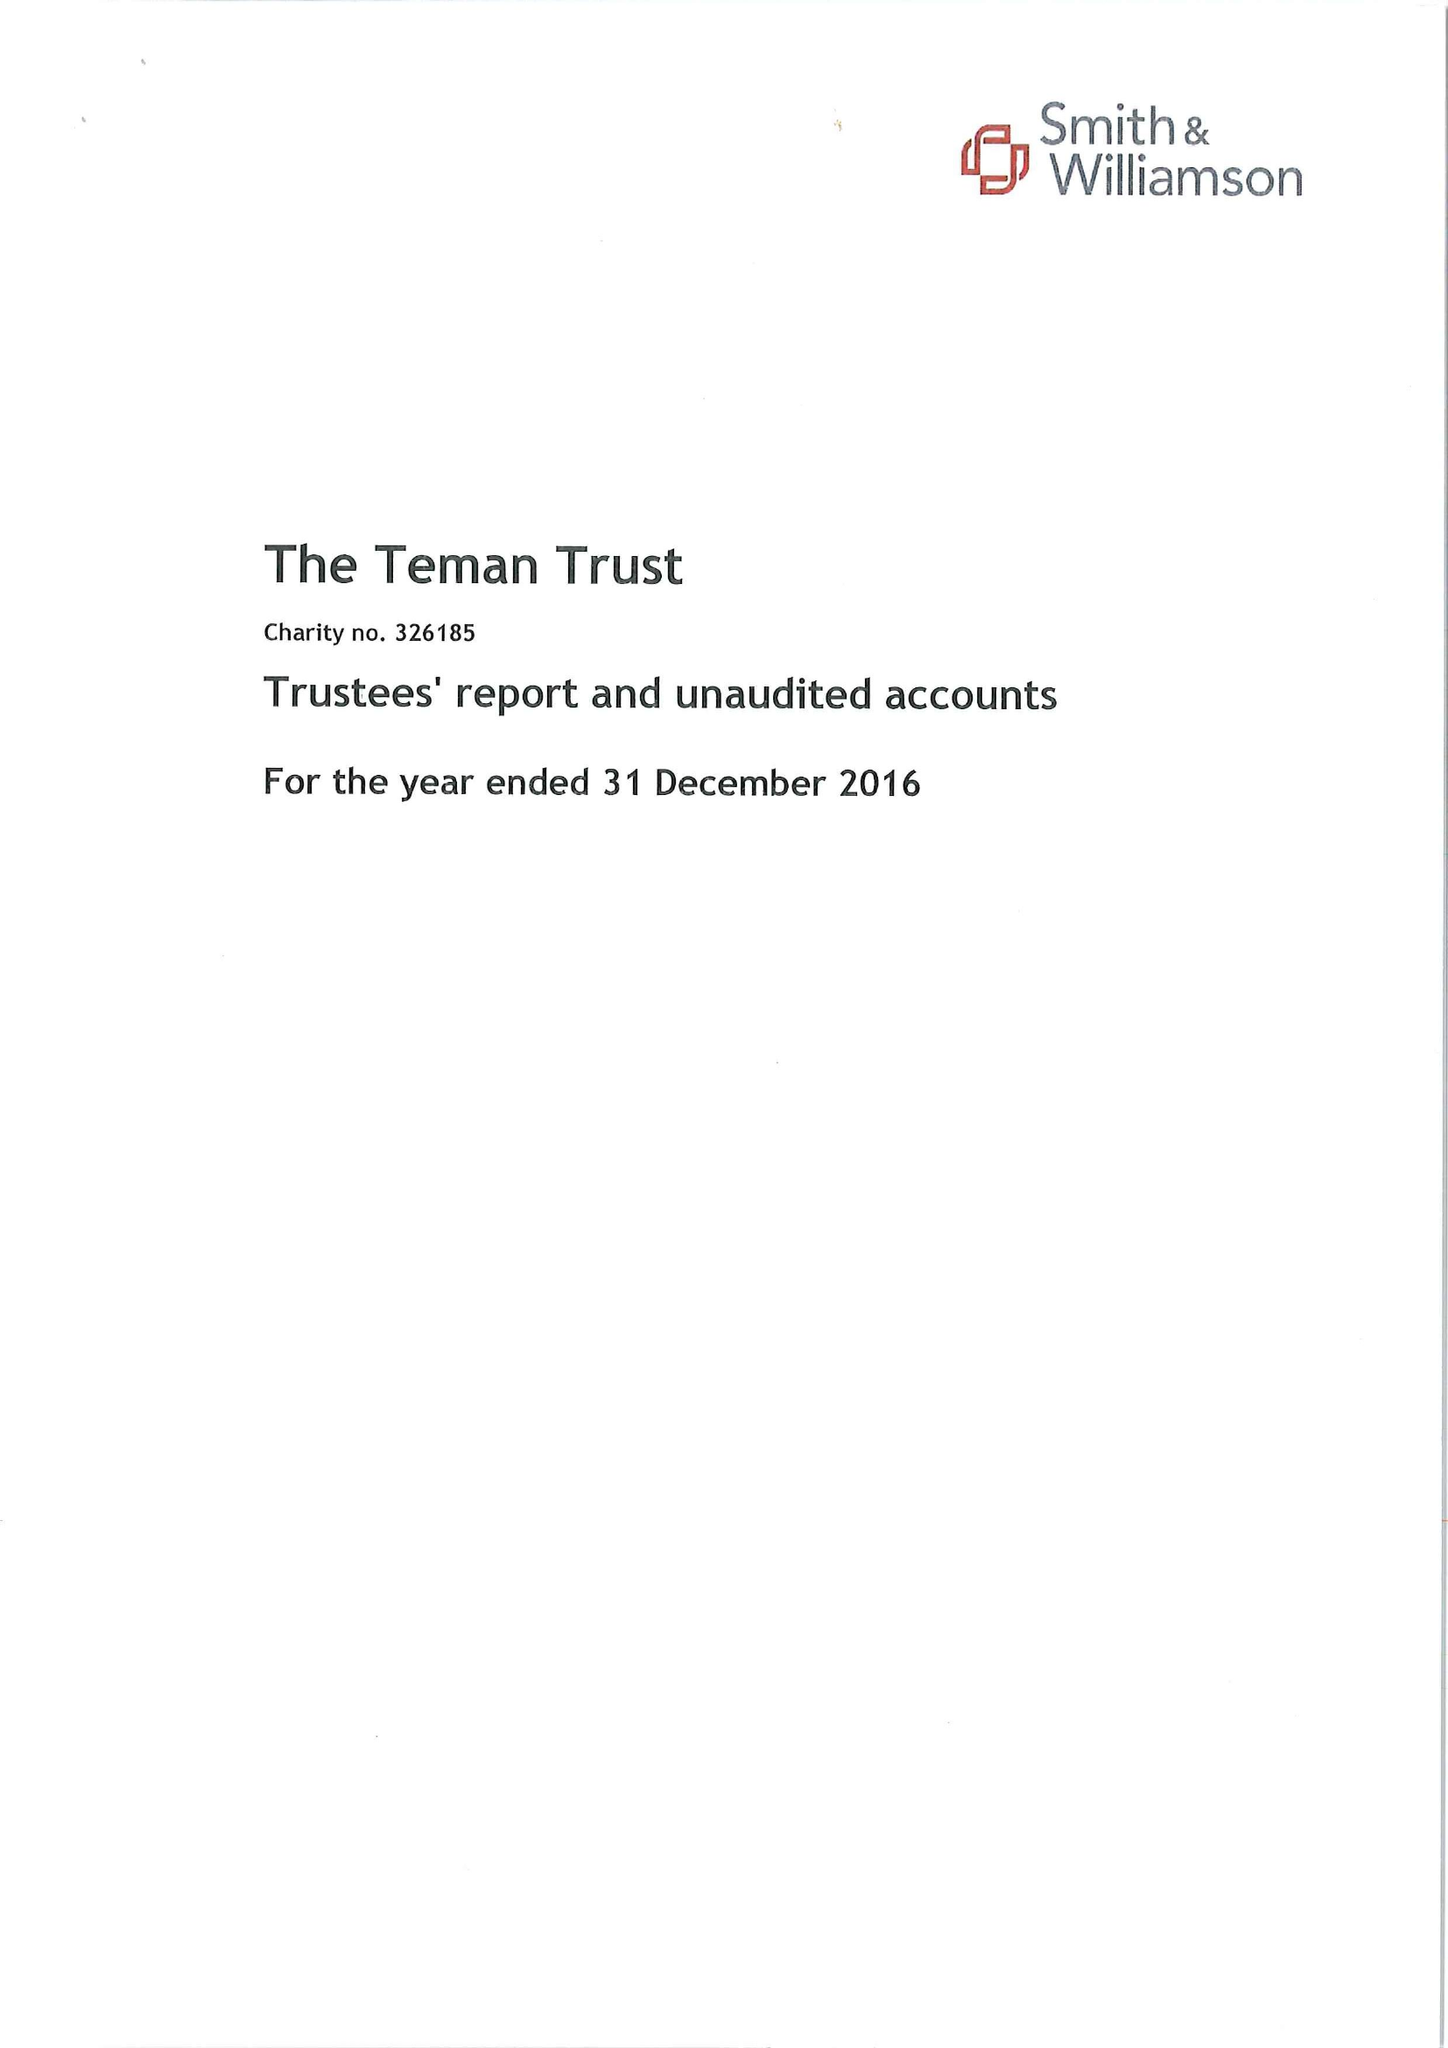What is the value for the charity_name?
Answer the question using a single word or phrase. The Teman Trust 